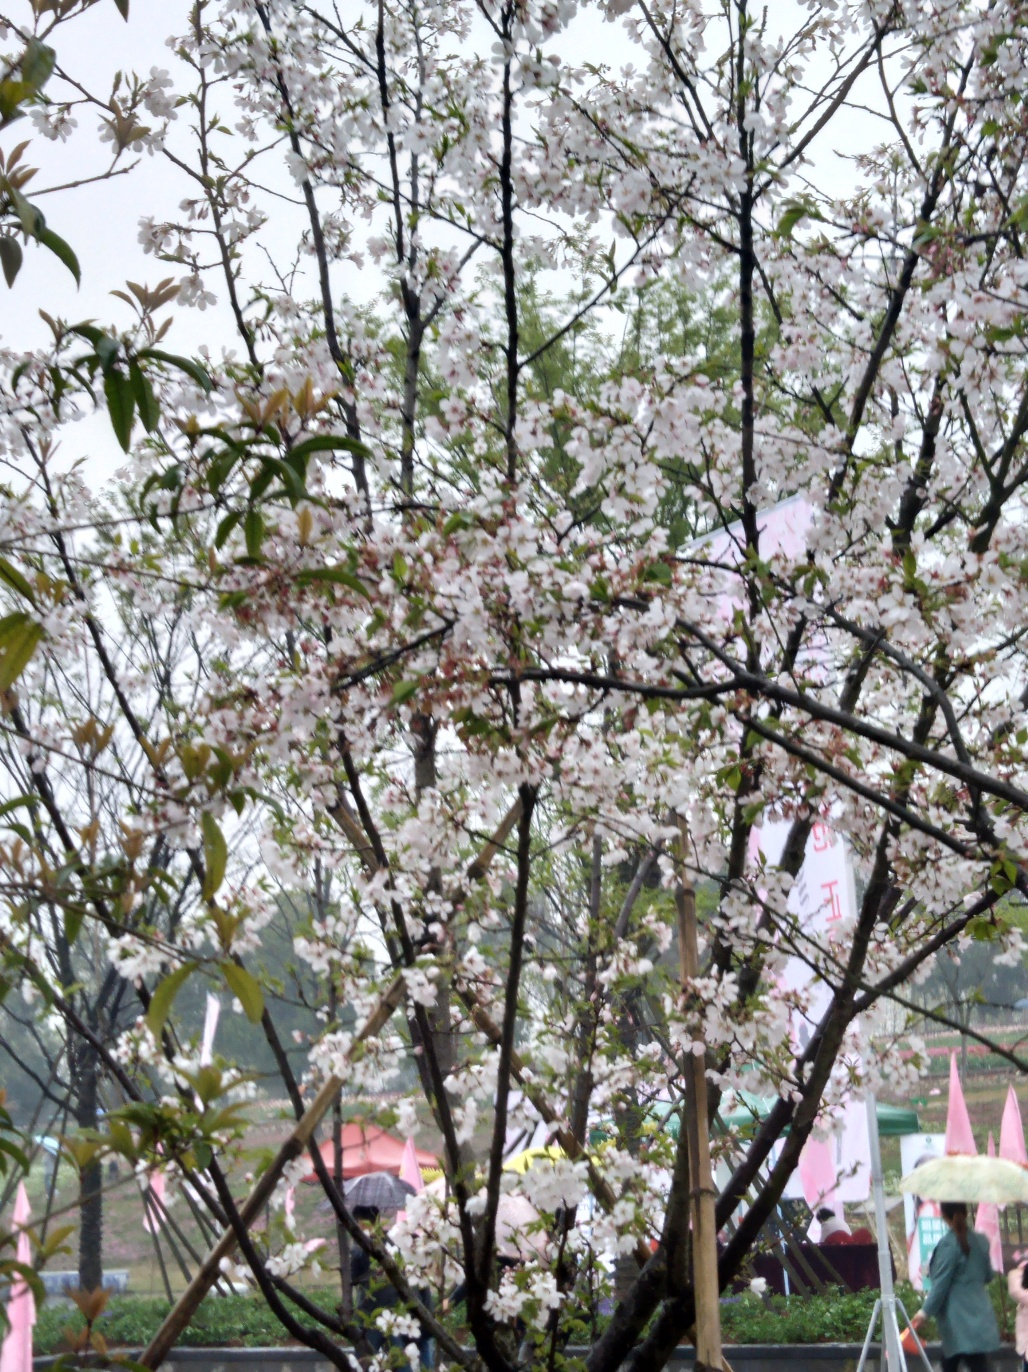What is the overall clarity of this image? The overall clarity of this image is moderate, with sufficient detail to recognize the flowering tree and the ambient setting, including what appears to be a canopy, despite some hazing, possibly due to weather conditions or photographic processing. 